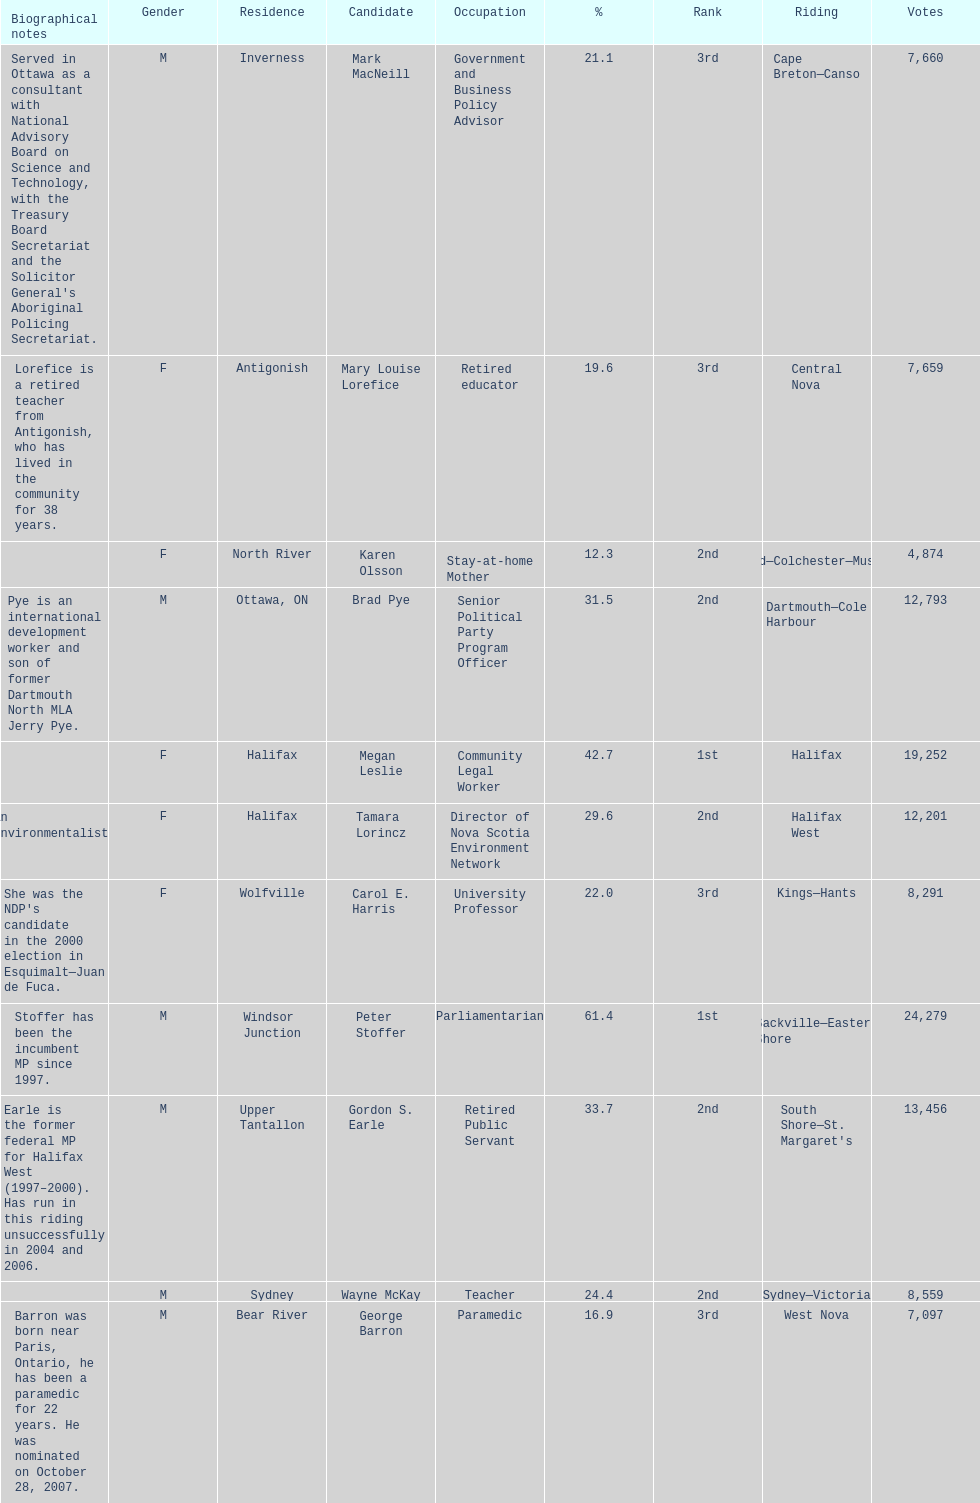Who has the most votes? Sackville-Eastern Shore. 